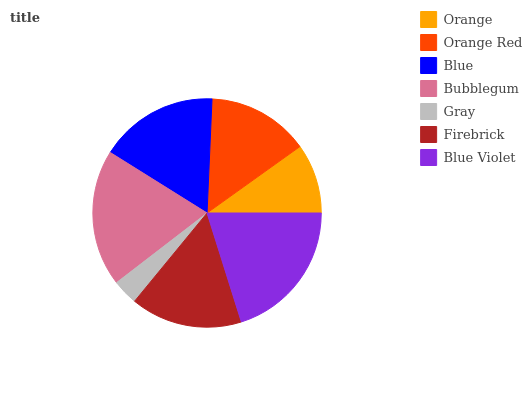Is Gray the minimum?
Answer yes or no. Yes. Is Blue Violet the maximum?
Answer yes or no. Yes. Is Orange Red the minimum?
Answer yes or no. No. Is Orange Red the maximum?
Answer yes or no. No. Is Orange Red greater than Orange?
Answer yes or no. Yes. Is Orange less than Orange Red?
Answer yes or no. Yes. Is Orange greater than Orange Red?
Answer yes or no. No. Is Orange Red less than Orange?
Answer yes or no. No. Is Firebrick the high median?
Answer yes or no. Yes. Is Firebrick the low median?
Answer yes or no. Yes. Is Blue Violet the high median?
Answer yes or no. No. Is Orange the low median?
Answer yes or no. No. 